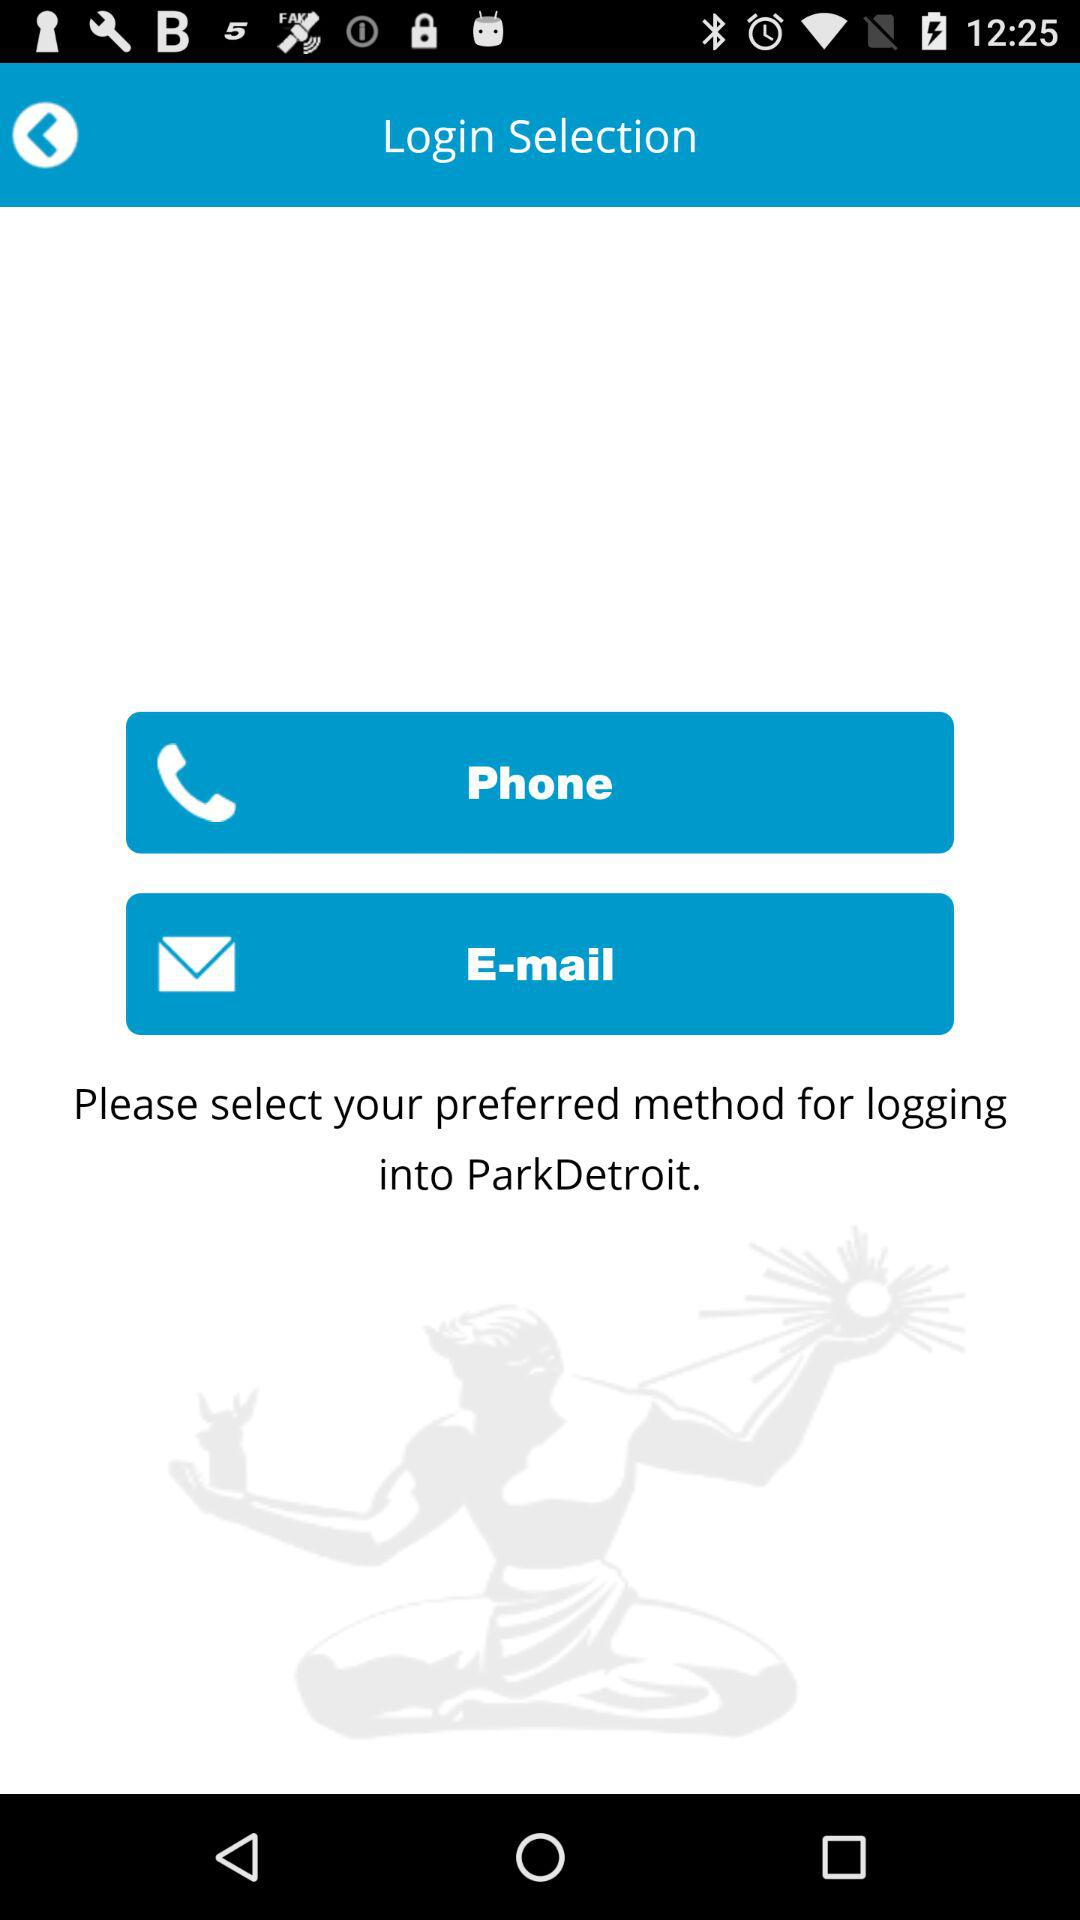What is the name of the application? The name of the application is "ParkDetroit". 